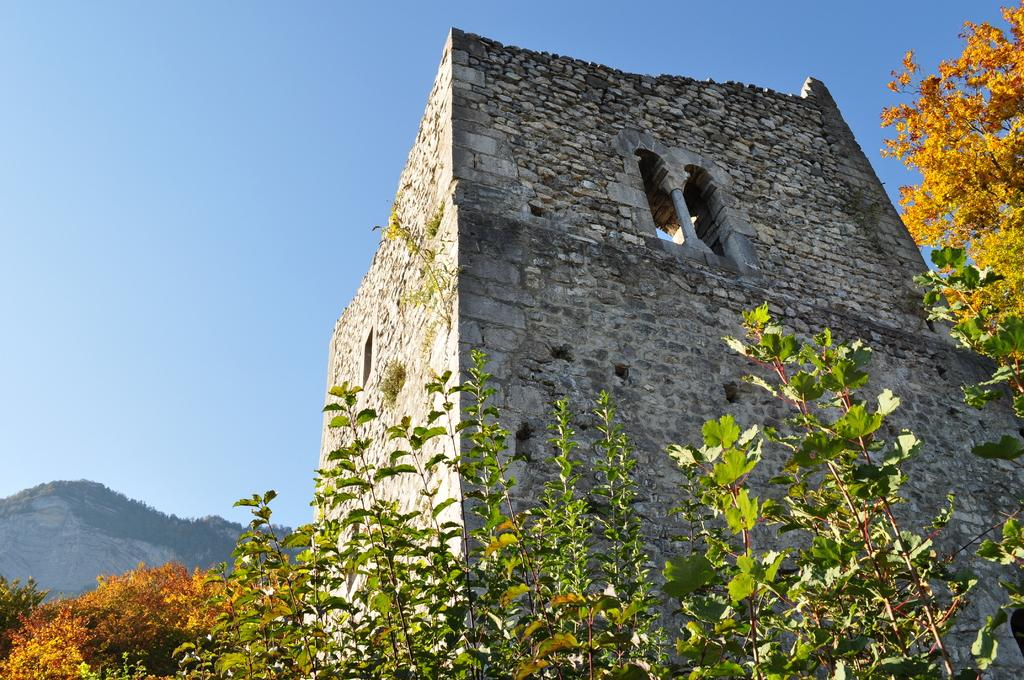What type of structure is visible in the image? There is a building with windows in the image. What can be seen in the foreground of the image? There are plants in the foreground of the image. What is visible in the background of the image? There is a group of trees, a hill, and the sky visible in the background of the image. What grade of jelly is being used to hold the building in place in the image? There is no jelly present in the image, and the building is not being held in place by any substance. 